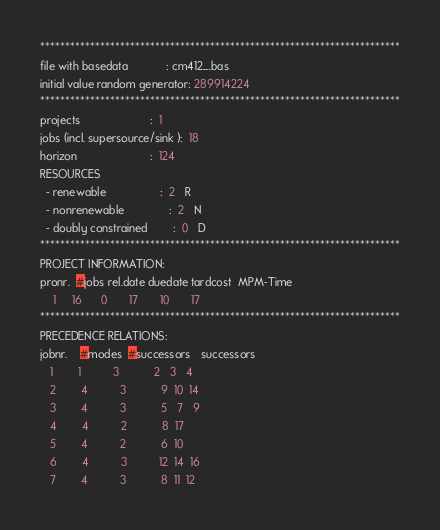Convert code to text. <code><loc_0><loc_0><loc_500><loc_500><_ObjectiveC_>************************************************************************
file with basedata            : cm412_.bas
initial value random generator: 289914224
************************************************************************
projects                      :  1
jobs (incl. supersource/sink ):  18
horizon                       :  124
RESOURCES
  - renewable                 :  2   R
  - nonrenewable              :  2   N
  - doubly constrained        :  0   D
************************************************************************
PROJECT INFORMATION:
pronr.  #jobs rel.date duedate tardcost  MPM-Time
    1     16      0       17       10       17
************************************************************************
PRECEDENCE RELATIONS:
jobnr.    #modes  #successors   successors
   1        1          3           2   3   4
   2        4          3           9  10  14
   3        4          3           5   7   9
   4        4          2           8  17
   5        4          2           6  10
   6        4          3          12  14  16
   7        4          3           8  11  12</code> 